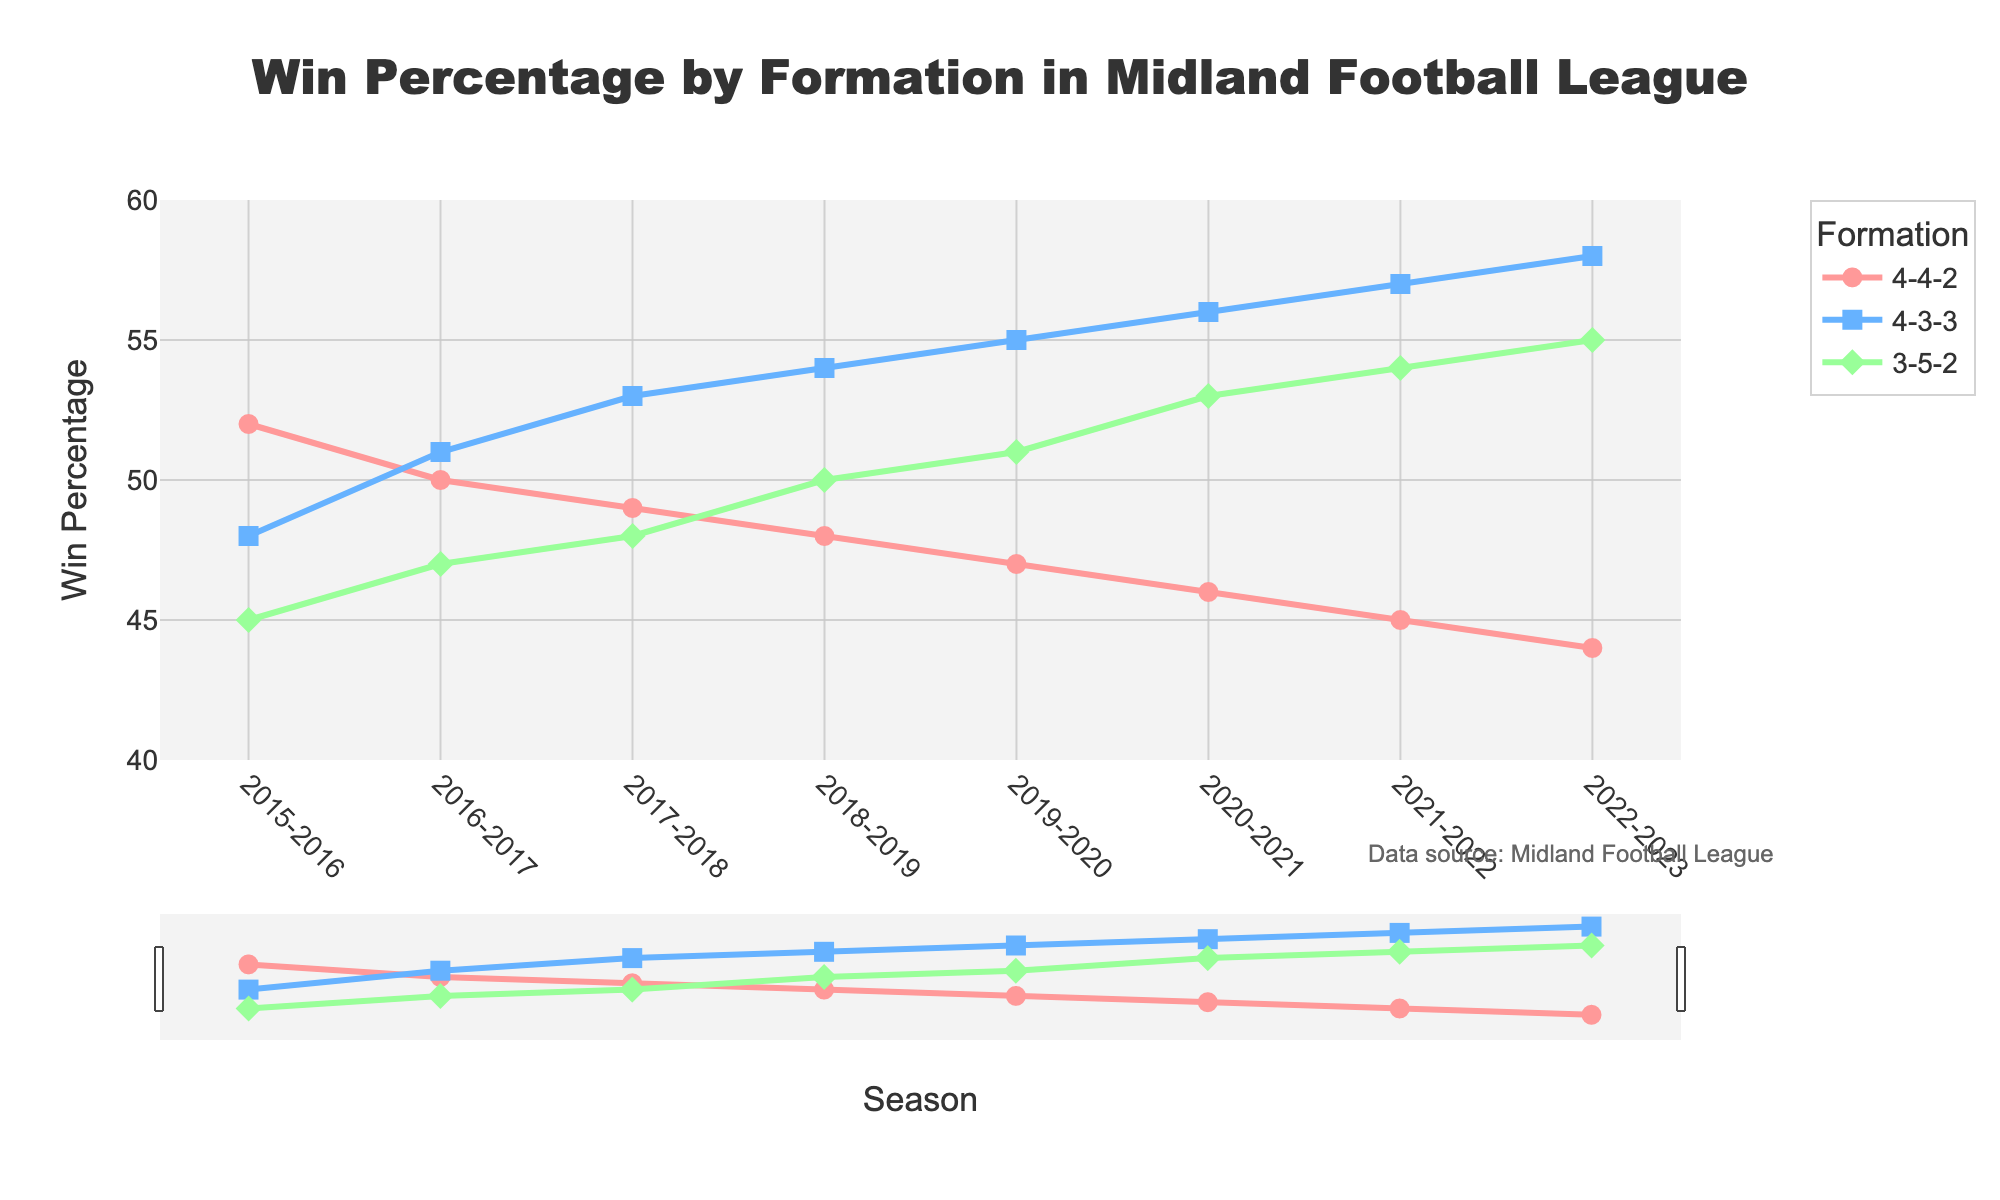What's the win percentage of the 4-4-2 formation in the 2015-2016 season? Look at the starting point of the red line representing the 4-4-2 formation, locate the 2015-2016 season on the x-axis, and read the y-value.
Answer: 52% Which formation had the highest win percentage in the 2018-2019 season? Compare the heights of the lines for all three formations in the 2018-2019 season. The blue line for the 4-3-3 formation is the highest.
Answer: 4-3-3 By how many percentage points did the win percentage of the 4-3-3 formation increase from the 2015-2016 season to the 2022-2023 season? The win percentage of the 4-3-3 formation in the 2015-2016 season is 48%. In the 2022-2023 season, it is 58%. Calculate the difference: 58% - 48% = 10%.
Answer: 10% Which formation showed a consistent increase in win percentage across the seasons? Observe the trends of each line. The blue line representing the 4-3-3 formation shows a consistent upward trend.
Answer: 4-3-3 In which season did the 3-5-2 formation's win percentage first surpass 50%? Find the green line representing the 3-5-2 formation and locate the first season where the y-value is greater than 50%. The 2019-2020 season shows a value of 51%.
Answer: 2019-2020 How many seasons did the 4-4-2 formation have a higher win percentage than the 3-5-2 formation? Compare the win percentages of the 4-4-2 and 3-5-2 formations for each season. The seasons 2015-2016, 2016-2017, and 2017-2018 show higher values for 4-4-2.
Answer: 3 seasons What is the average win percentage of the 3-5-2 formation across all the seasons? Sum the win percentages of the 3-5-2 formation for all seasons: 45 + 47 + 48 + 50 + 51 + 53 + 54 + 55 = 403. Divide by the number of seasons (8): 403/8 = 50.375%.
Answer: 50.375% Which season experienced the smallest difference in win percentage between the 4-4-2 and 4-3-3 formations? Calculate the differences for each season and find the smallest: 2016-2017: 1% (51-50), 2017-2018: 4% (53-49), 2018-2019: 6% (54-48), etc. The 2016-2017 season has the smallest difference.
Answer: 2016-2017 Over the period shown, which formation's win percentage decreased the most? Compare the starting and ending points of each line. The red line for the 4-4-2 formation decreased from 52% to 44%, an 8% decrease.
Answer: 4-4-2 In which season did all the formations have win percentages between 45% and 55%? Review each season to find when all values are within the specified range. The 2017-2018 season shows 4-4-2: 49%, 4-3-3: 53%, and 3-5-2: 48%.
Answer: 2017-2018 